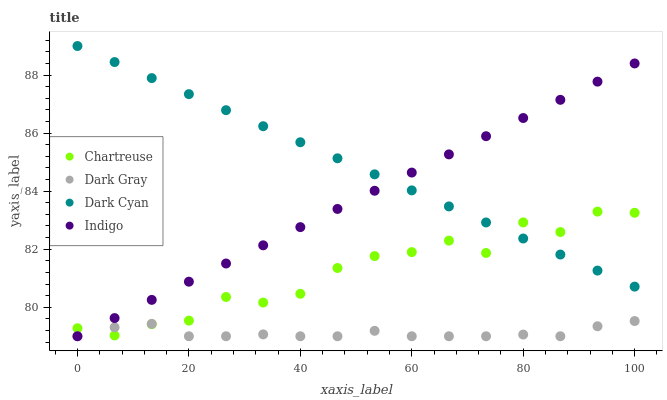Does Dark Gray have the minimum area under the curve?
Answer yes or no. Yes. Does Dark Cyan have the maximum area under the curve?
Answer yes or no. Yes. Does Chartreuse have the minimum area under the curve?
Answer yes or no. No. Does Chartreuse have the maximum area under the curve?
Answer yes or no. No. Is Dark Cyan the smoothest?
Answer yes or no. Yes. Is Chartreuse the roughest?
Answer yes or no. Yes. Is Chartreuse the smoothest?
Answer yes or no. No. Is Dark Cyan the roughest?
Answer yes or no. No. Does Dark Gray have the lowest value?
Answer yes or no. Yes. Does Chartreuse have the lowest value?
Answer yes or no. No. Does Dark Cyan have the highest value?
Answer yes or no. Yes. Does Chartreuse have the highest value?
Answer yes or no. No. Is Dark Gray less than Dark Cyan?
Answer yes or no. Yes. Is Dark Cyan greater than Dark Gray?
Answer yes or no. Yes. Does Indigo intersect Dark Cyan?
Answer yes or no. Yes. Is Indigo less than Dark Cyan?
Answer yes or no. No. Is Indigo greater than Dark Cyan?
Answer yes or no. No. Does Dark Gray intersect Dark Cyan?
Answer yes or no. No. 